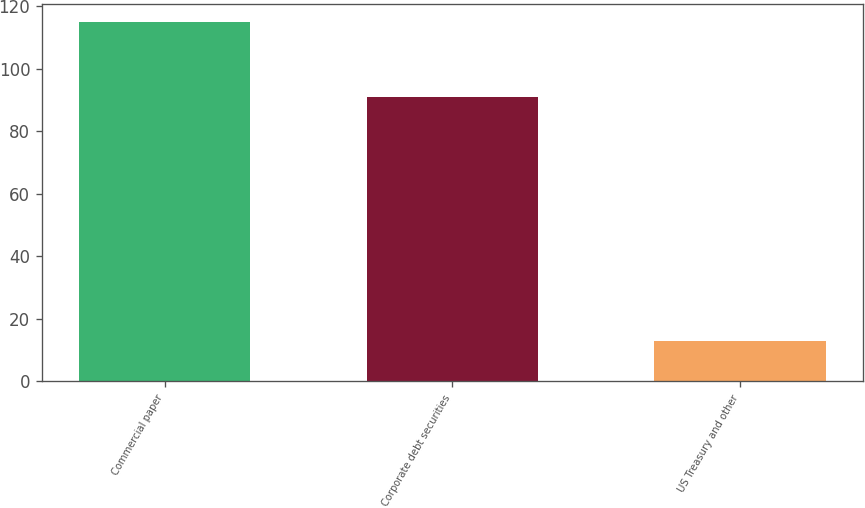Convert chart. <chart><loc_0><loc_0><loc_500><loc_500><bar_chart><fcel>Commercial paper<fcel>Corporate debt securities<fcel>US Treasury and other<nl><fcel>115<fcel>91<fcel>13<nl></chart> 